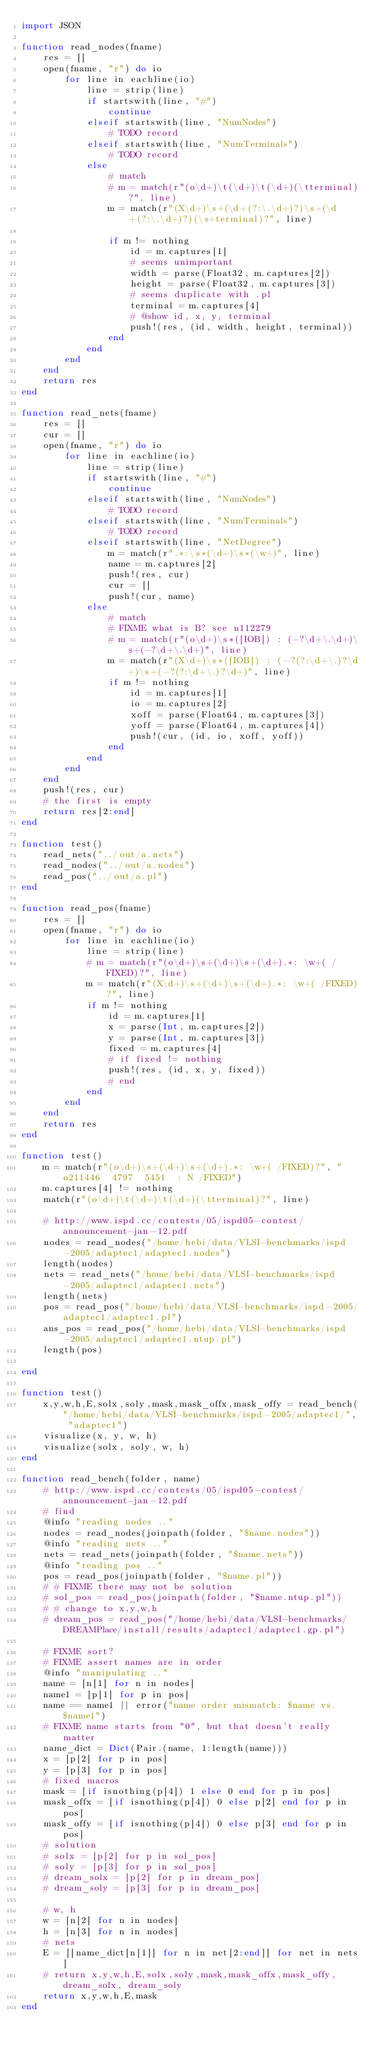<code> <loc_0><loc_0><loc_500><loc_500><_Julia_>import JSON

function read_nodes(fname)
    res = []
    open(fname, "r") do io
        for line in eachline(io)
            line = strip(line)
            if startswith(line, "#")
                continue
            elseif startswith(line, "NumNodes")
                # TODO record
            elseif startswith(line, "NumTerminals")
                # TODO record
            else
                # match
                # m = match(r"(o\d+)\t(\d+)\t(\d+)(\tterminal)?", line)
                m = match(r"(X\d+)\s+(\d+(?:\.\d+)?)\s+(\d+(?:\.\d+)?)(\s+terminal)?", line)
                
                if m != nothing
                    id = m.captures[1]
                    # seems unimportant
                    width = parse(Float32, m.captures[2])
                    height = parse(Float32, m.captures[3])
                    # seems duplicate with .pl
                    terminal = m.captures[4]
                    # @show id, x, y, terminal
                    push!(res, (id, width, height, terminal))
                end
            end
        end
    end
    return res
end

function read_nets(fname)
    res = []
    cur = []
    open(fname, "r") do io
        for line in eachline(io)
            line = strip(line)
            if startswith(line, "#")
                continue
            elseif startswith(line, "NumNodes")
                # TODO record
            elseif startswith(line, "NumTerminals")
                # TODO record
            elseif startswith(line, "NetDegree")
                m = match(r".*:\s*(\d+)\s*(\w+)", line)
                name = m.captures[2]
                push!(res, cur)
                cur = []
                push!(cur, name)
            else
                # match
                # FIXME what is B? see n112279
                # m = match(r"(o\d+)\s*([IOB]) : (-?\d+\.\d+)\s+(-?\d+\.\d+)", line)
                m = match(r"(X\d+)\s*([IOB]) : (-?(?:\d+\.)?\d+)\s+(-?(?:\d+\.)?\d+)", line)
                if m != nothing
                    id = m.captures[1]
                    io = m.captures[2]
                    xoff = parse(Float64, m.captures[3])
                    yoff = parse(Float64, m.captures[4])
                    push!(cur, (id, io, xoff, yoff))
                end
            end
        end
    end
    push!(res, cur)
    # the first is empty
    return res[2:end]
end

function test()
    read_nets("../out/a.nets")
    read_nodes("../out/a.nodes")
    read_pos("../out/a.pl")
end

function read_pos(fname)
    res = []
    open(fname, "r") do io
        for line in eachline(io)
            line = strip(line)
            # m = match(r"(o\d+)\s+(\d+)\s+(\d+).*: \w+( /FIXED)?", line)
            m = match(r"(X\d+)\s+(\d+)\s+(\d+).*: \w+( /FIXED)?", line)
            if m != nothing
                id = m.captures[1]
                x = parse(Int, m.captures[2])
                y = parse(Int, m.captures[3])
                fixed = m.captures[4]
                # if fixed != nothing
                push!(res, (id, x, y, fixed))
                # end
            end
        end
    end
    return res
end

function test()
    m = match(r"(o\d+)\s+(\d+)\s+(\d+).*: \w+( /FIXED)?", "o211446	4797	5451	: N /FIXED")
    m.captures[4] != nothing
    match(r"(o\d+)\t(\d+)\t(\d+)(\tterminal)?", line)

    # http://www.ispd.cc/contests/05/ispd05-contest/announcement-jan-12.pdf
    nodes = read_nodes("/home/hebi/data/VLSI-benchmarks/ispd-2005/adaptec1/adaptec1.nodes")
    length(nodes)
    nets = read_nets("/home/hebi/data/VLSI-benchmarks/ispd-2005/adaptec1/adaptec1.nets")
    length(nets)
    pos = read_pos("/home/hebi/data/VLSI-benchmarks/ispd-2005/adaptec1/adaptec1.pl")
    ans_pos = read_pos("/home/hebi/data/VLSI-benchmarks/ispd-2005/adaptec1/adaptec1.ntup.pl")
    length(pos)

end

function test()
    x,y,w,h,E,solx,soly,mask,mask_offx,mask_offy = read_bench("/home/hebi/data/VLSI-benchmarks/ispd-2005/adaptec1/", "adaptec1")
    visualize(x, y, w, h)
    visualize(solx, soly, w, h)
end

function read_bench(folder, name)
    # http://www.ispd.cc/contests/05/ispd05-contest/announcement-jan-12.pdf
    # find
    @info "reading nodes .."
    nodes = read_nodes(joinpath(folder, "$name.nodes"))
    @info "reading nets .."
    nets = read_nets(joinpath(folder, "$name.nets"))
    @info "reading pos .."
    pos = read_pos(joinpath(folder, "$name.pl"))
    # # FIXME there may not be solution
    # sol_pos = read_pos(joinpath(folder, "$name.ntup.pl"))
    # # change to x,y,w,h
    # dream_pos = read_pos("/home/hebi/data/VLSI-benchmarks/DREAMPlace/install/results/adaptec1/adaptec1.gp.pl")

    # FIXME sort?
    # FIXME assert names are in order
    @info "manipulating .."
    name = [n[1] for n in nodes]
    name1 = [p[1] for p in pos]
    name == name1 || error("name order mismatch: $name vs. $name1")
    # FIXME name starts from "0", but that doesn't really matter
    name_dict = Dict(Pair.(name, 1:length(name)))
    x = [p[2] for p in pos]
    y = [p[3] for p in pos]
    # fixed macros
    mask = [if isnothing(p[4]) 1 else 0 end for p in pos]
    mask_offx = [if isnothing(p[4]) 0 else p[2] end for p in pos]
    mask_offy = [if isnothing(p[4]) 0 else p[3] end for p in pos]
    # solution
    # solx = [p[2] for p in sol_pos]
    # soly = [p[3] for p in sol_pos]
    # dream_solx = [p[2] for p in dream_pos]
    # dream_soly = [p[3] for p in dream_pos]
    
    # w, h
    w = [n[2] for n in nodes]
    h = [n[3] for n in nodes]
    # nets
    E = [[name_dict[n[1]] for n in net[2:end]] for net in nets]
    # return x,y,w,h,E,solx,soly,mask,mask_offx,mask_offy, dream_solx, dream_soly
    return x,y,w,h,E,mask
end
</code> 